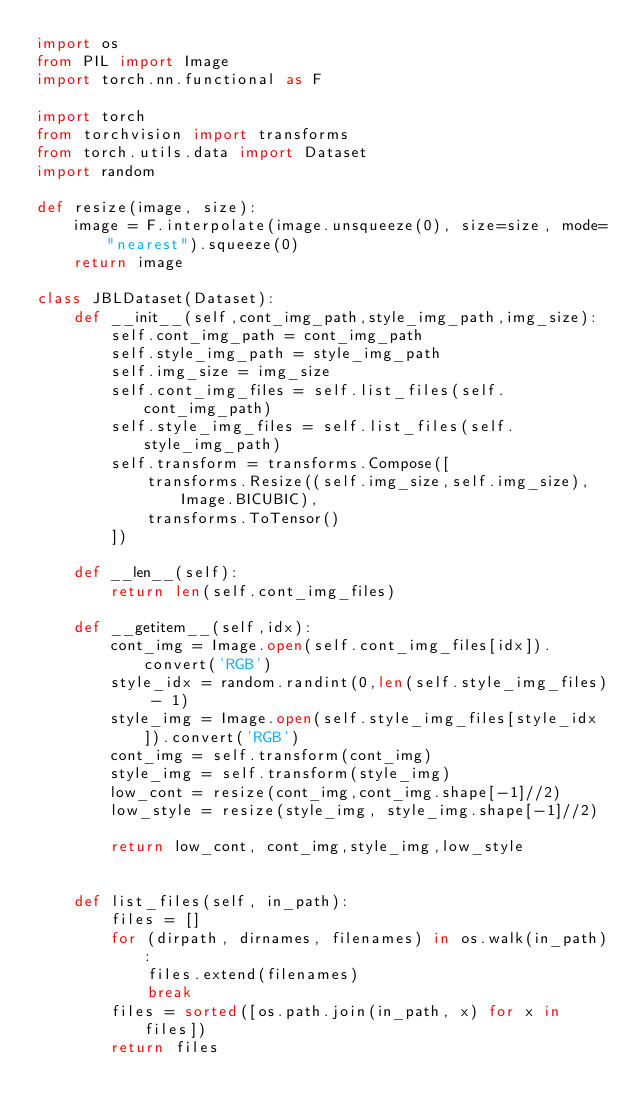Convert code to text. <code><loc_0><loc_0><loc_500><loc_500><_Python_>import os
from PIL import Image
import torch.nn.functional as F

import torch
from torchvision import transforms
from torch.utils.data import Dataset
import random

def resize(image, size):
    image = F.interpolate(image.unsqueeze(0), size=size, mode="nearest").squeeze(0)
    return image

class JBLDataset(Dataset):
    def __init__(self,cont_img_path,style_img_path,img_size):
        self.cont_img_path = cont_img_path
        self.style_img_path = style_img_path
        self.img_size = img_size
        self.cont_img_files = self.list_files(self.cont_img_path)
        self.style_img_files = self.list_files(self.style_img_path)
        self.transform = transforms.Compose([
            transforms.Resize((self.img_size,self.img_size), Image.BICUBIC),
            transforms.ToTensor()
        ])

    def __len__(self):
        return len(self.cont_img_files)

    def __getitem__(self,idx):
        cont_img = Image.open(self.cont_img_files[idx]).convert('RGB')
        style_idx = random.randint(0,len(self.style_img_files) - 1)
        style_img = Image.open(self.style_img_files[style_idx]).convert('RGB')
        cont_img = self.transform(cont_img)
        style_img = self.transform(style_img)
        low_cont = resize(cont_img,cont_img.shape[-1]//2)
        low_style = resize(style_img, style_img.shape[-1]//2)

        return low_cont, cont_img,style_img,low_style


    def list_files(self, in_path):
        files = []
        for (dirpath, dirnames, filenames) in os.walk(in_path):
            files.extend(filenames)
            break
        files = sorted([os.path.join(in_path, x) for x in files])
        return files

</code> 